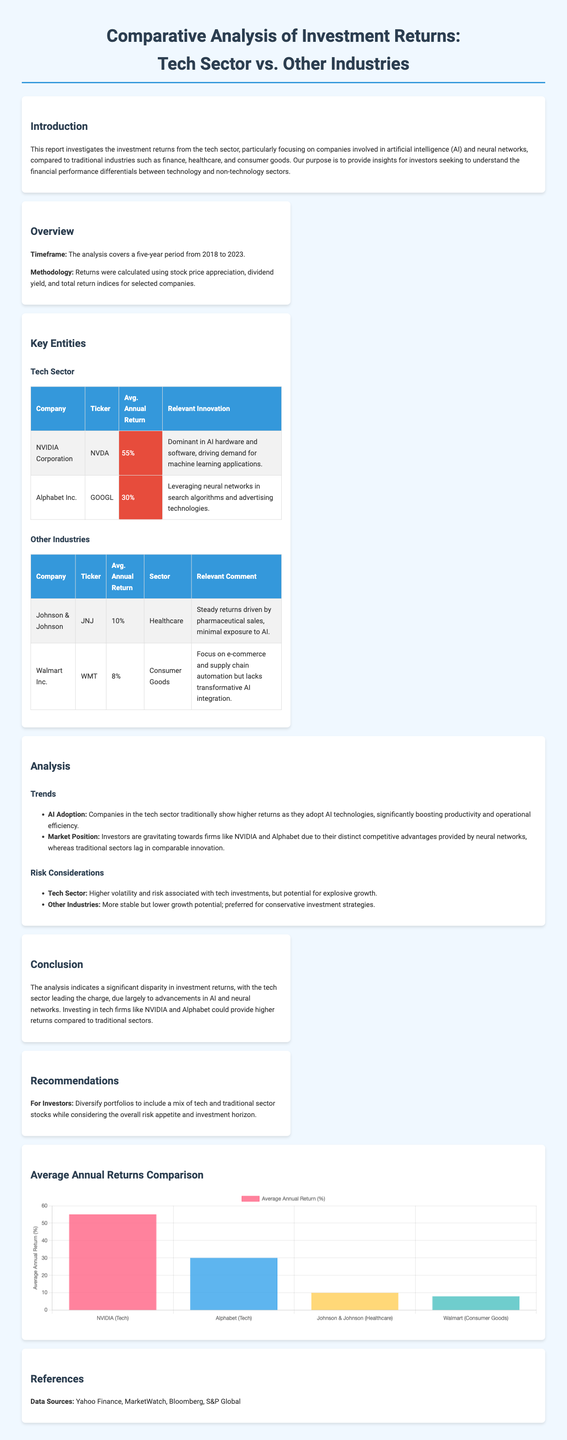What is the average annual return for NVIDIA Corporation? The average annual return for NVIDIA Corporation is highlighted in the document, which states it is 55%.
Answer: 55% What relevant innovation does Alphabet Inc. leverage? The document mentions that Alphabet Inc. leverages neural networks in search algorithms and advertising technologies.
Answer: Neural networks in search algorithms and advertising technologies What is the average annual return for Walmart Inc.? Walmart Inc.'s average annual return is provided as 8% in the document.
Answer: 8% What are the primary sectors compared in the report? The report discusses the tech sector compared to traditional industries such as finance, healthcare, and consumer goods.
Answer: Tech sector and traditional industries Which company had a 10% average annual return? The document specifies Johnson & Johnson with an average annual return of 10%.
Answer: Johnson & Johnson Describe the risk associated with the tech sector according to the report. The document highlights that the tech sector carries higher volatility and risk but potential for explosive growth.
Answer: Higher volatility and risk; potential for explosive growth What is the focus of the analysis timeframe? The analysis timeframe specified in the document extends over a five-year period from 2018 to 2023.
Answer: Five years from 2018 to 2023 What is recommended for investors in the report? The report recommends that investors diversify portfolios while considering their overall risk appetite and investment horizon.
Answer: Diversify portfolios considering risk appetite and investment horizon 